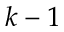Convert formula to latex. <formula><loc_0><loc_0><loc_500><loc_500>k - 1</formula> 